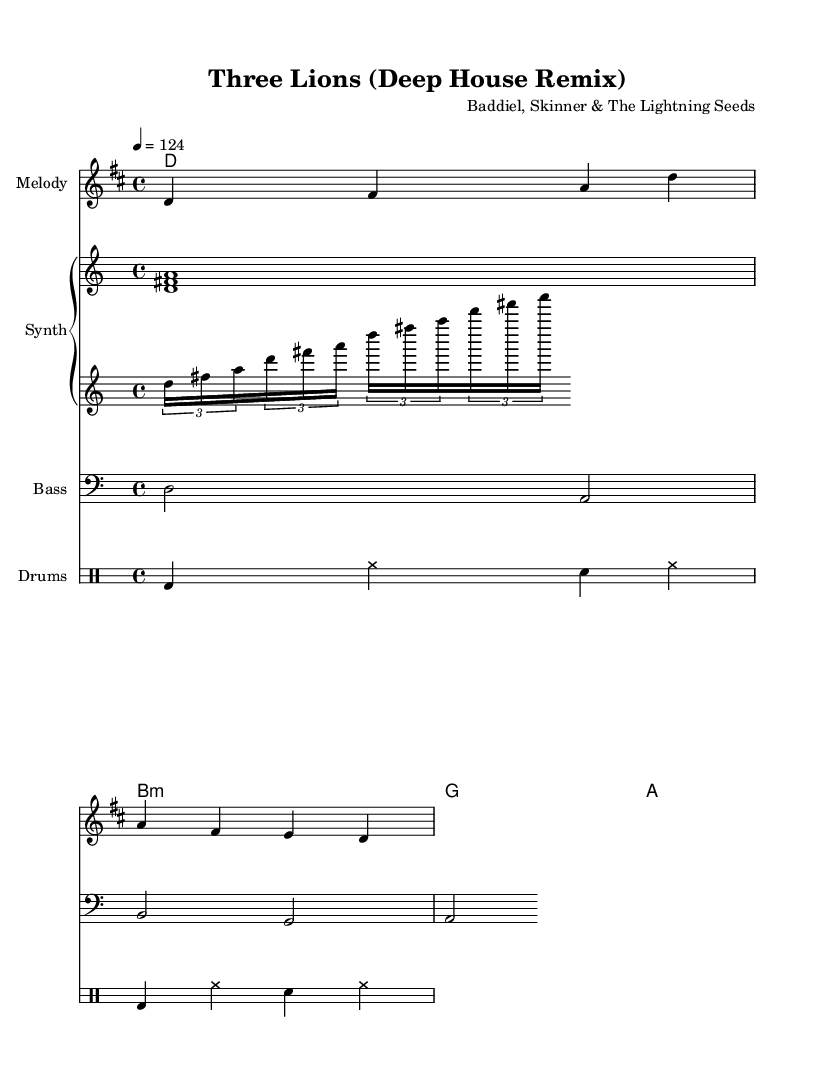What is the key signature of this music? The key signature indicated by the 'key' directive is D major, which contains two sharps (F# and C#).
Answer: D major What is the time signature of this music? The time signature is shown at the beginning as 4/4, meaning there are four beats in each measure and a quarter note gets one beat.
Answer: 4/4 What is the tempo marking for this piece? The tempo marking in the score indicates a tempo of quarter note equals 124 beats per minute, providing the pacing for the rhythm of the music.
Answer: 124 How many measures are present in the melody section? Counting the number of distinct groupings of notes and rests in the melody line, there are 4 measures as outlined by the spaces between the note clusters.
Answer: 4 What is the predominant rhythmic pattern for the drums? Observing the drum staff, the pattern consists of bass drum (bd), hi-hat (hh), and snare drum (sn), repeated to create a danceable rhythm typical of house music.
Answer: bass, hi-hat, snare What type of chords are used in the harmony section? The harmony section shows major and minor chords: D major, B minor, G major, and A major, which are common in popular and house music for creating melodic tension and resolution.
Answer: Major and minor 